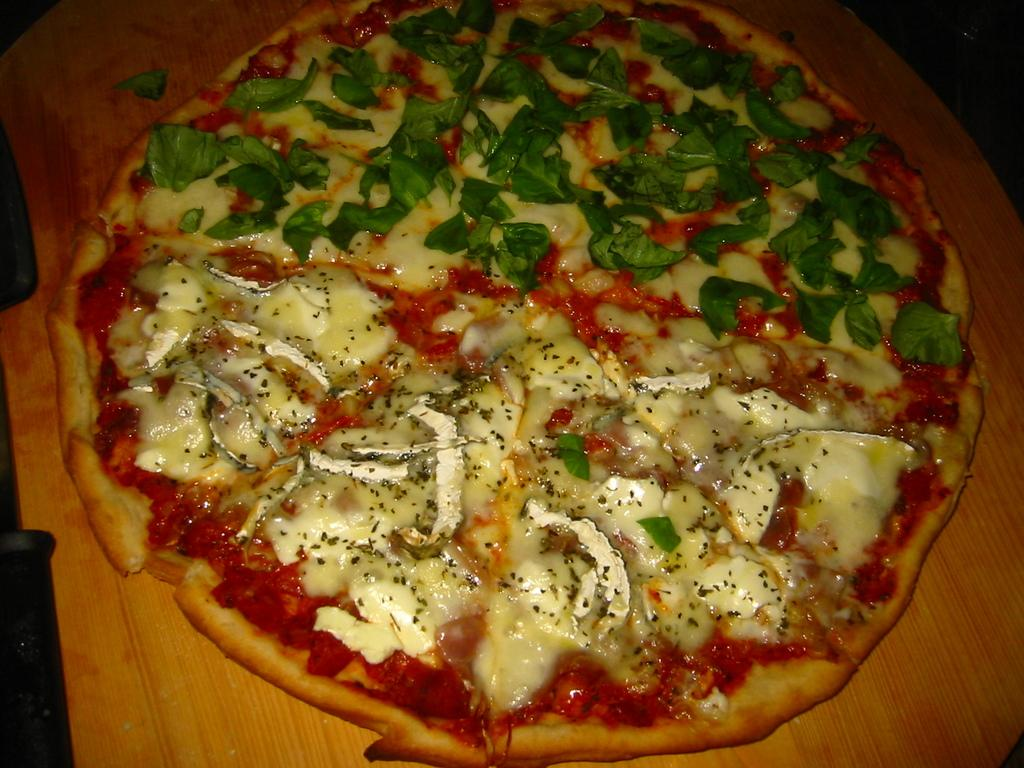What can be seen in the image related to food? There is food in the image. What is the color of the surface the food is on? The surface the food is on is brown in color. What type of collar can be seen on the food in the image? There is no collar present on the food in the image. What kind of flame is visible near the food in the image? There is no flame visible near the food in the image. 